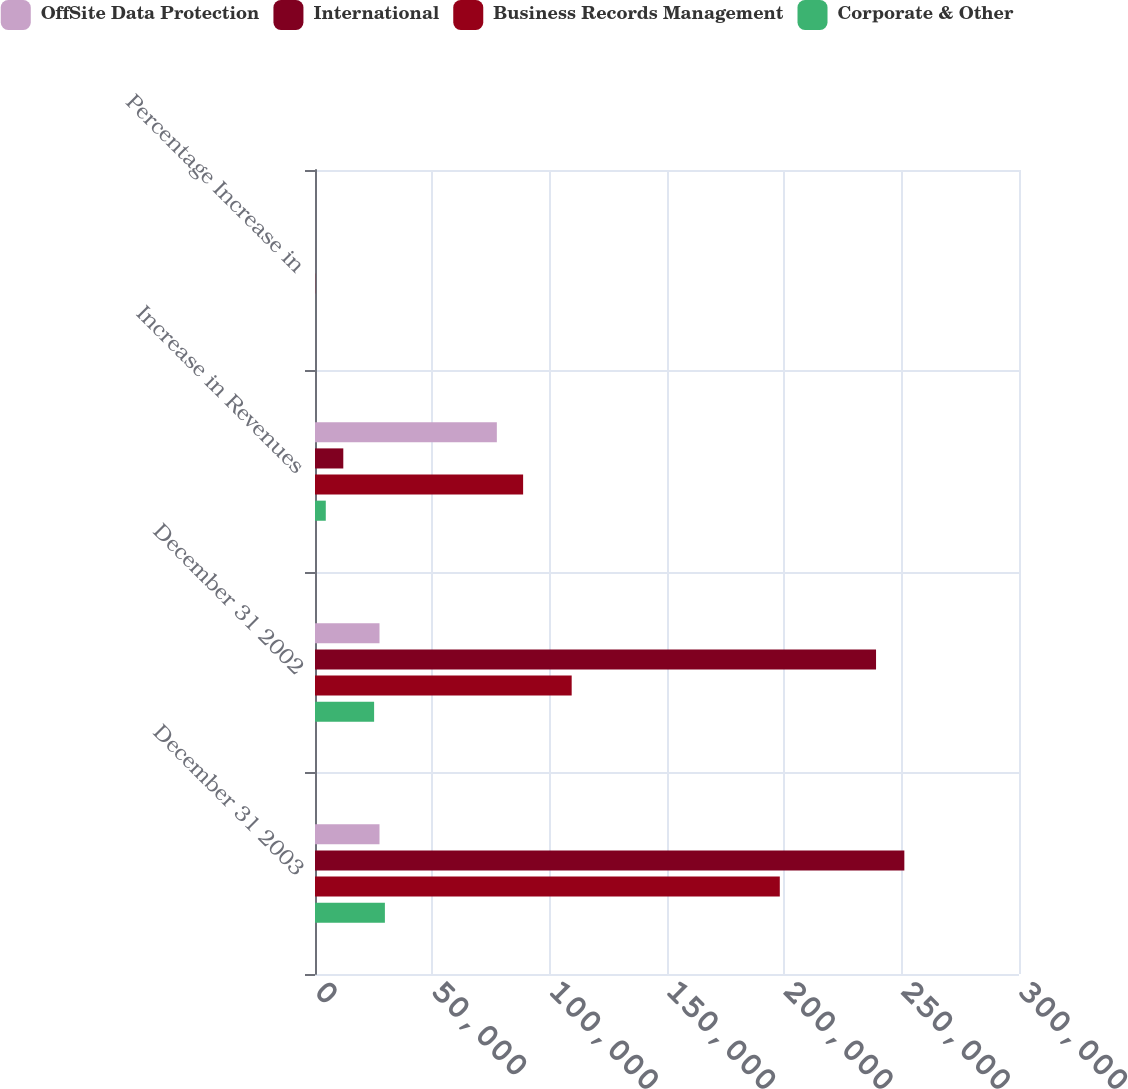Convert chart to OTSL. <chart><loc_0><loc_0><loc_500><loc_500><stacked_bar_chart><ecel><fcel>December 31 2003<fcel>December 31 2002<fcel>Increase in Revenues<fcel>Percentage Increase in<nl><fcel>OffSite Data Protection<fcel>27487.5<fcel>27487.5<fcel>77490<fcel>8.2<nl><fcel>International<fcel>251141<fcel>239081<fcel>12060<fcel>5<nl><fcel>Business Records Management<fcel>198068<fcel>109381<fcel>88687<fcel>81.1<nl><fcel>Corporate & Other<fcel>29785<fcel>25190<fcel>4595<fcel>18.2<nl></chart> 